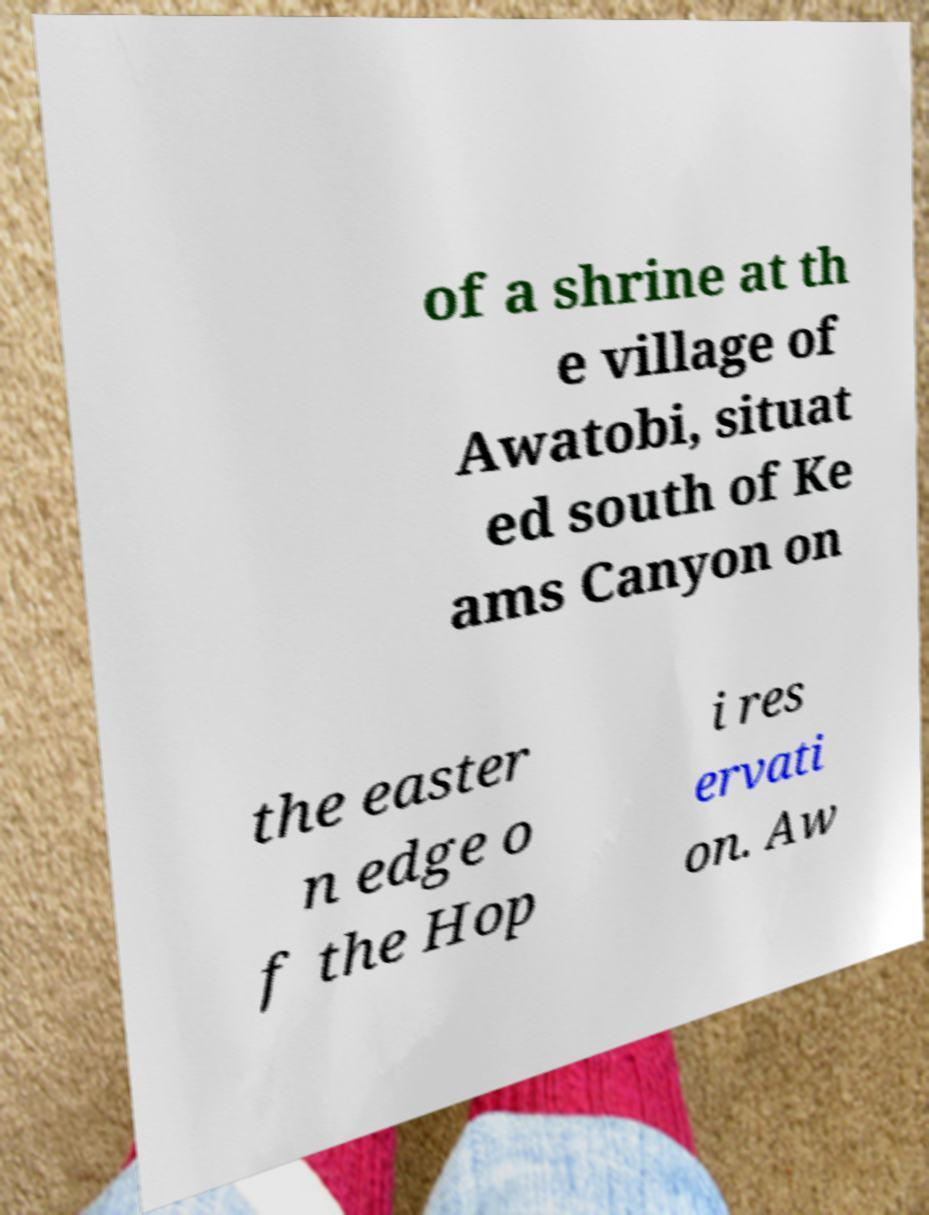There's text embedded in this image that I need extracted. Can you transcribe it verbatim? of a shrine at th e village of Awatobi, situat ed south of Ke ams Canyon on the easter n edge o f the Hop i res ervati on. Aw 